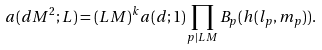Convert formula to latex. <formula><loc_0><loc_0><loc_500><loc_500>a ( d M ^ { 2 } ; L ) = ( L M ) ^ { k } a ( d ; 1 ) \prod _ { p | L M } B _ { p } ( h ( l _ { p } , m _ { p } ) ) .</formula> 